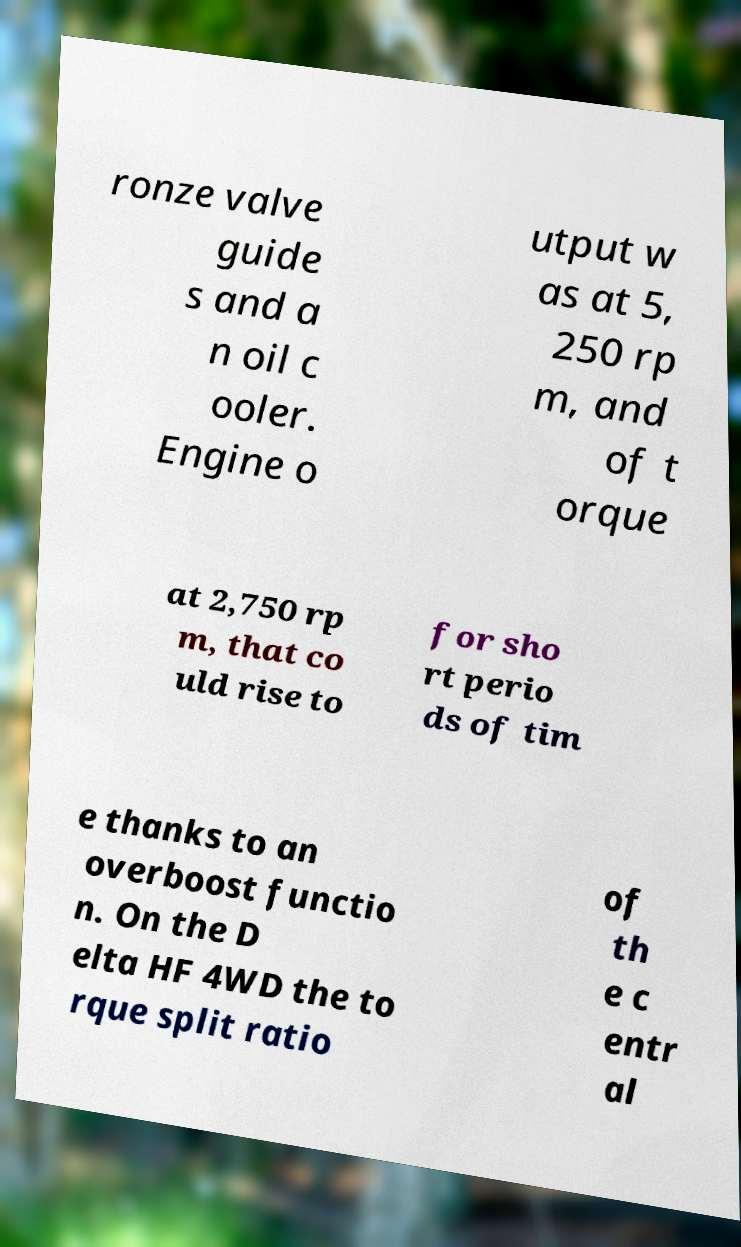Can you accurately transcribe the text from the provided image for me? ronze valve guide s and a n oil c ooler. Engine o utput w as at 5, 250 rp m, and of t orque at 2,750 rp m, that co uld rise to for sho rt perio ds of tim e thanks to an overboost functio n. On the D elta HF 4WD the to rque split ratio of th e c entr al 